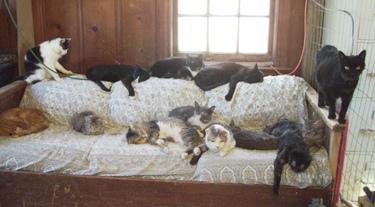What are the cats all on?
Write a very short answer. Couch. How many cats are here?
Concise answer only. 13. Where is the Tabby cat?
Keep it brief. Couch. 